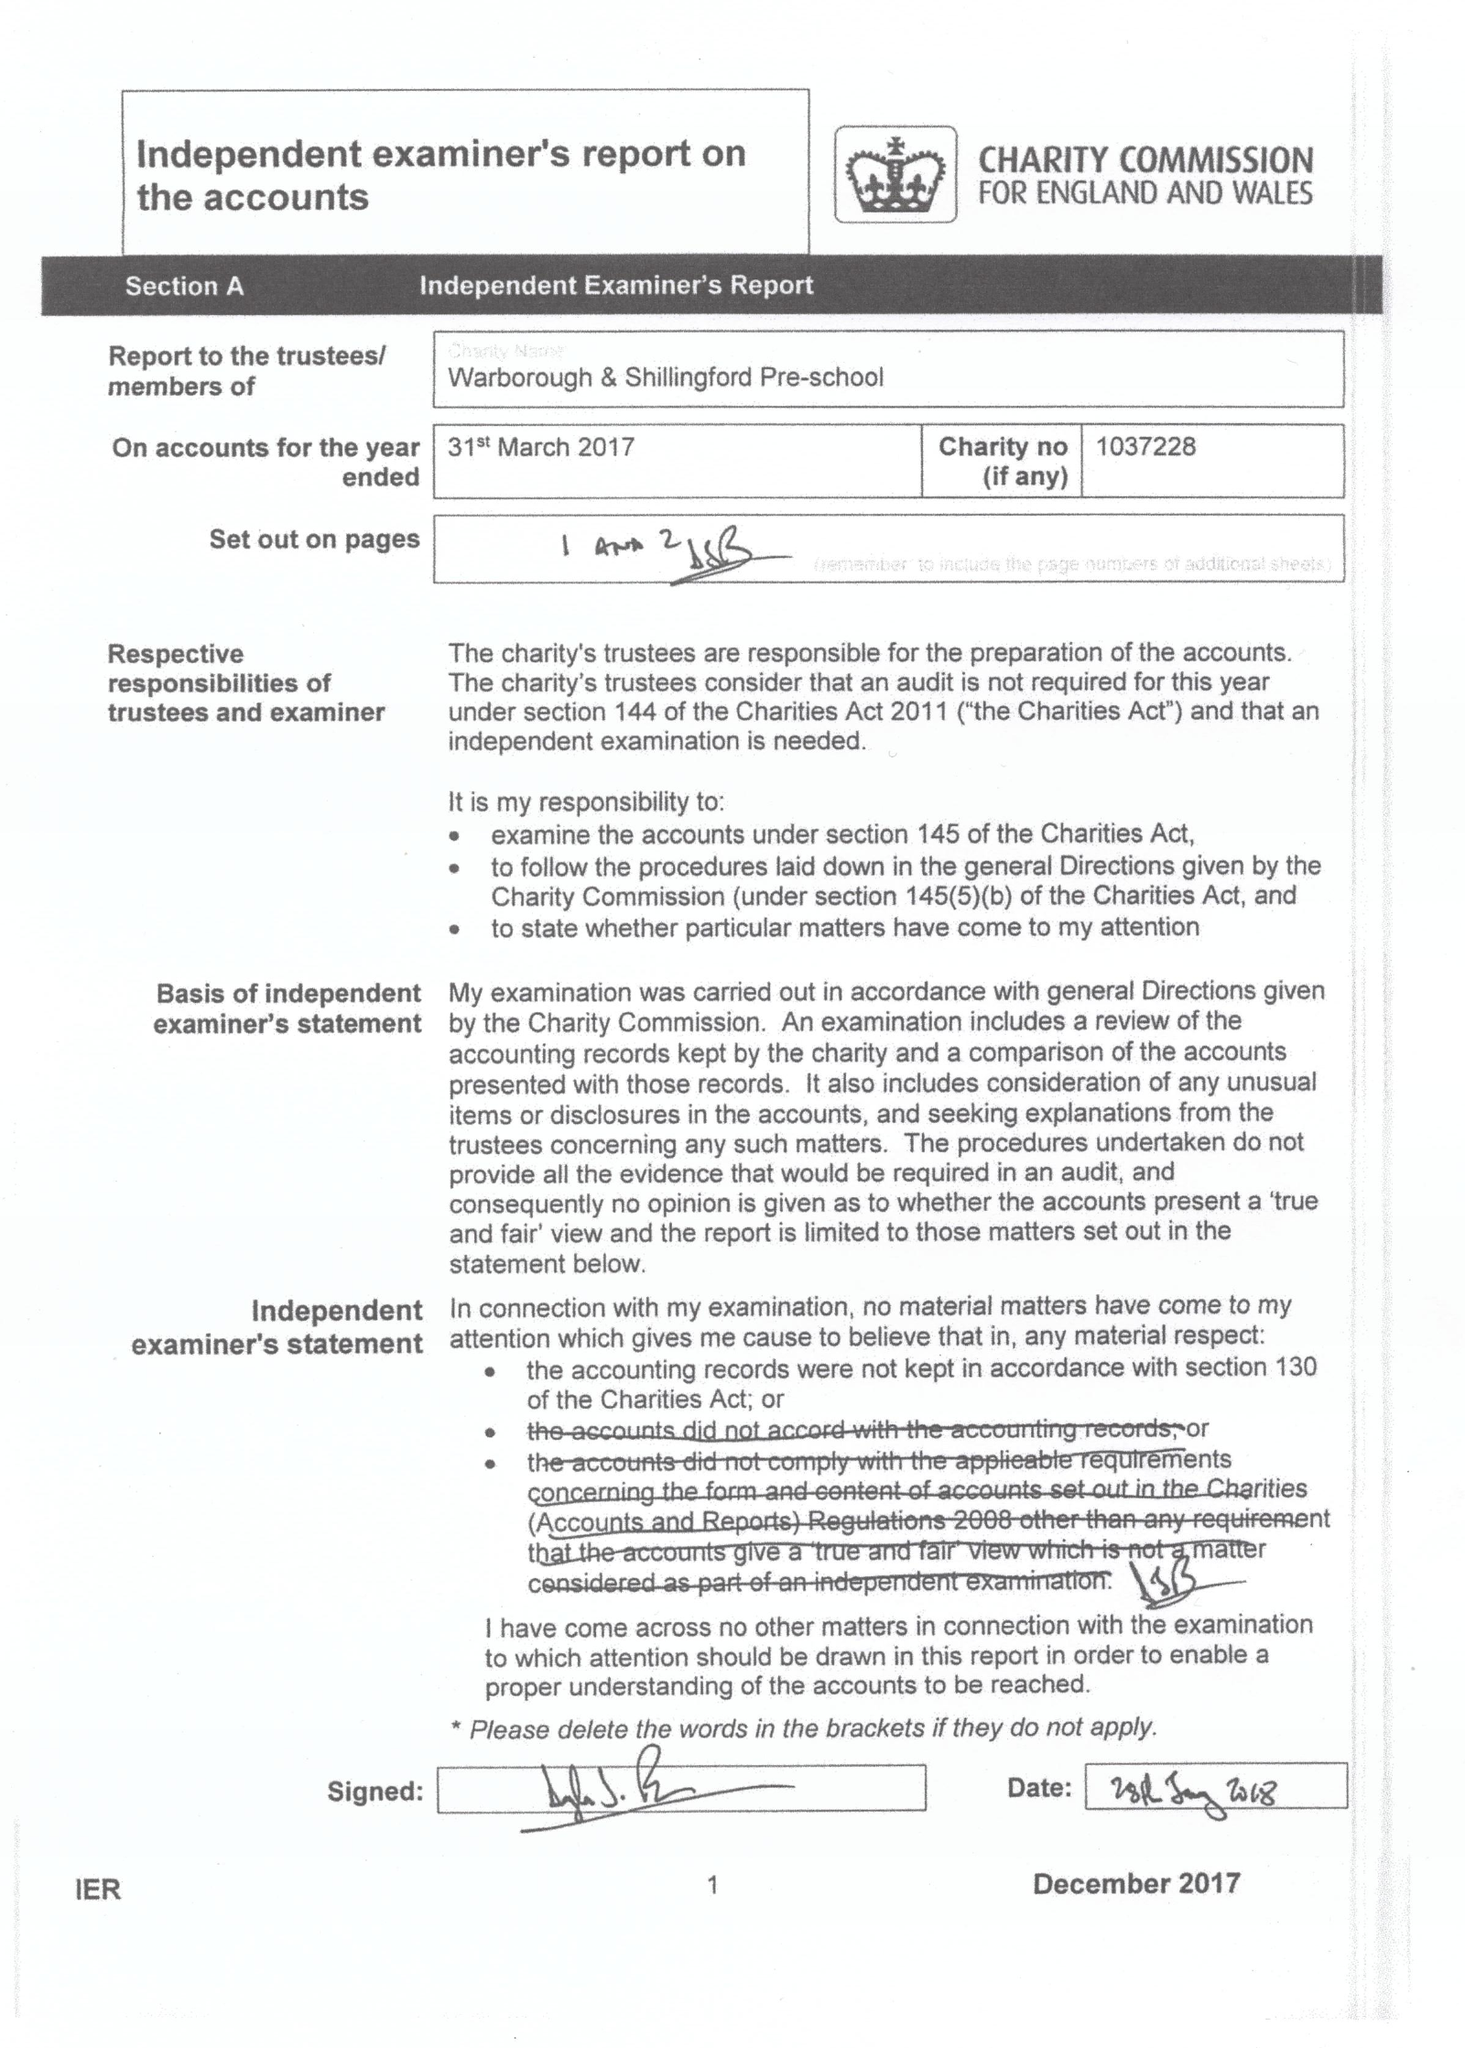What is the value for the income_annually_in_british_pounds?
Answer the question using a single word or phrase. 128912.00 